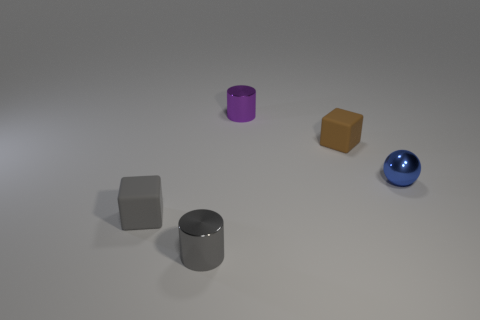Add 4 metallic balls. How many objects exist? 9 Subtract all spheres. How many objects are left? 4 Subtract 1 cylinders. How many cylinders are left? 1 Subtract all brown blocks. Subtract all red balls. How many blocks are left? 1 Subtract all red cylinders. How many brown cubes are left? 1 Subtract all small metallic balls. Subtract all tiny blue spheres. How many objects are left? 3 Add 4 rubber cubes. How many rubber cubes are left? 6 Add 4 small balls. How many small balls exist? 5 Subtract 0 red cubes. How many objects are left? 5 